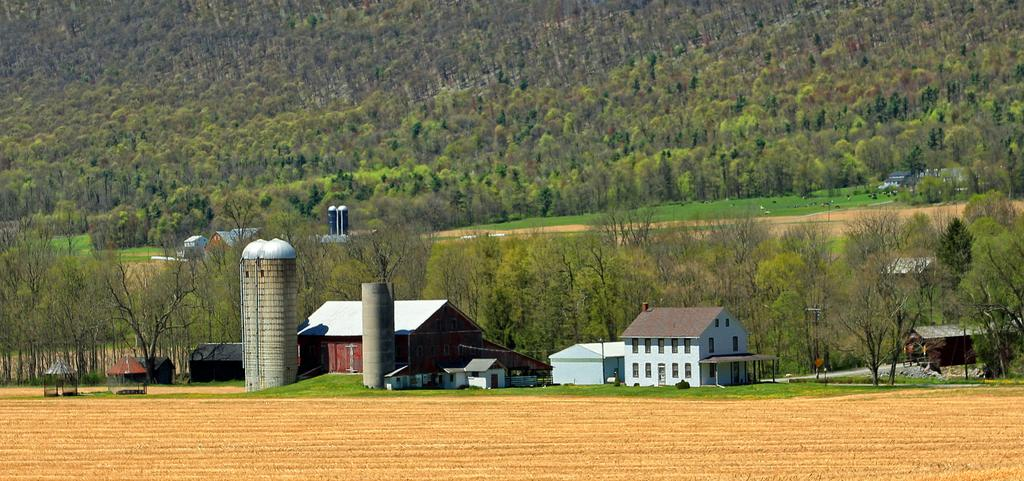What type of structures can be seen in the front of the image? There are houses in the front of the image. What type of vegetation is visible in the background of the image? There are trees in the background of the image. What type of ground cover is present on the left side in the front? There is grass on the ground on the left side in the front. What type of terrain is visible in the front of the image? There is dry land in the front of the image. What type of sock is being worn by the authority figure in the image? There is no authority figure or sock present in the image. What type of pleasure can be derived from the image? The image does not depict any pleasurable activity or object, so it cannot be determined from the image. 